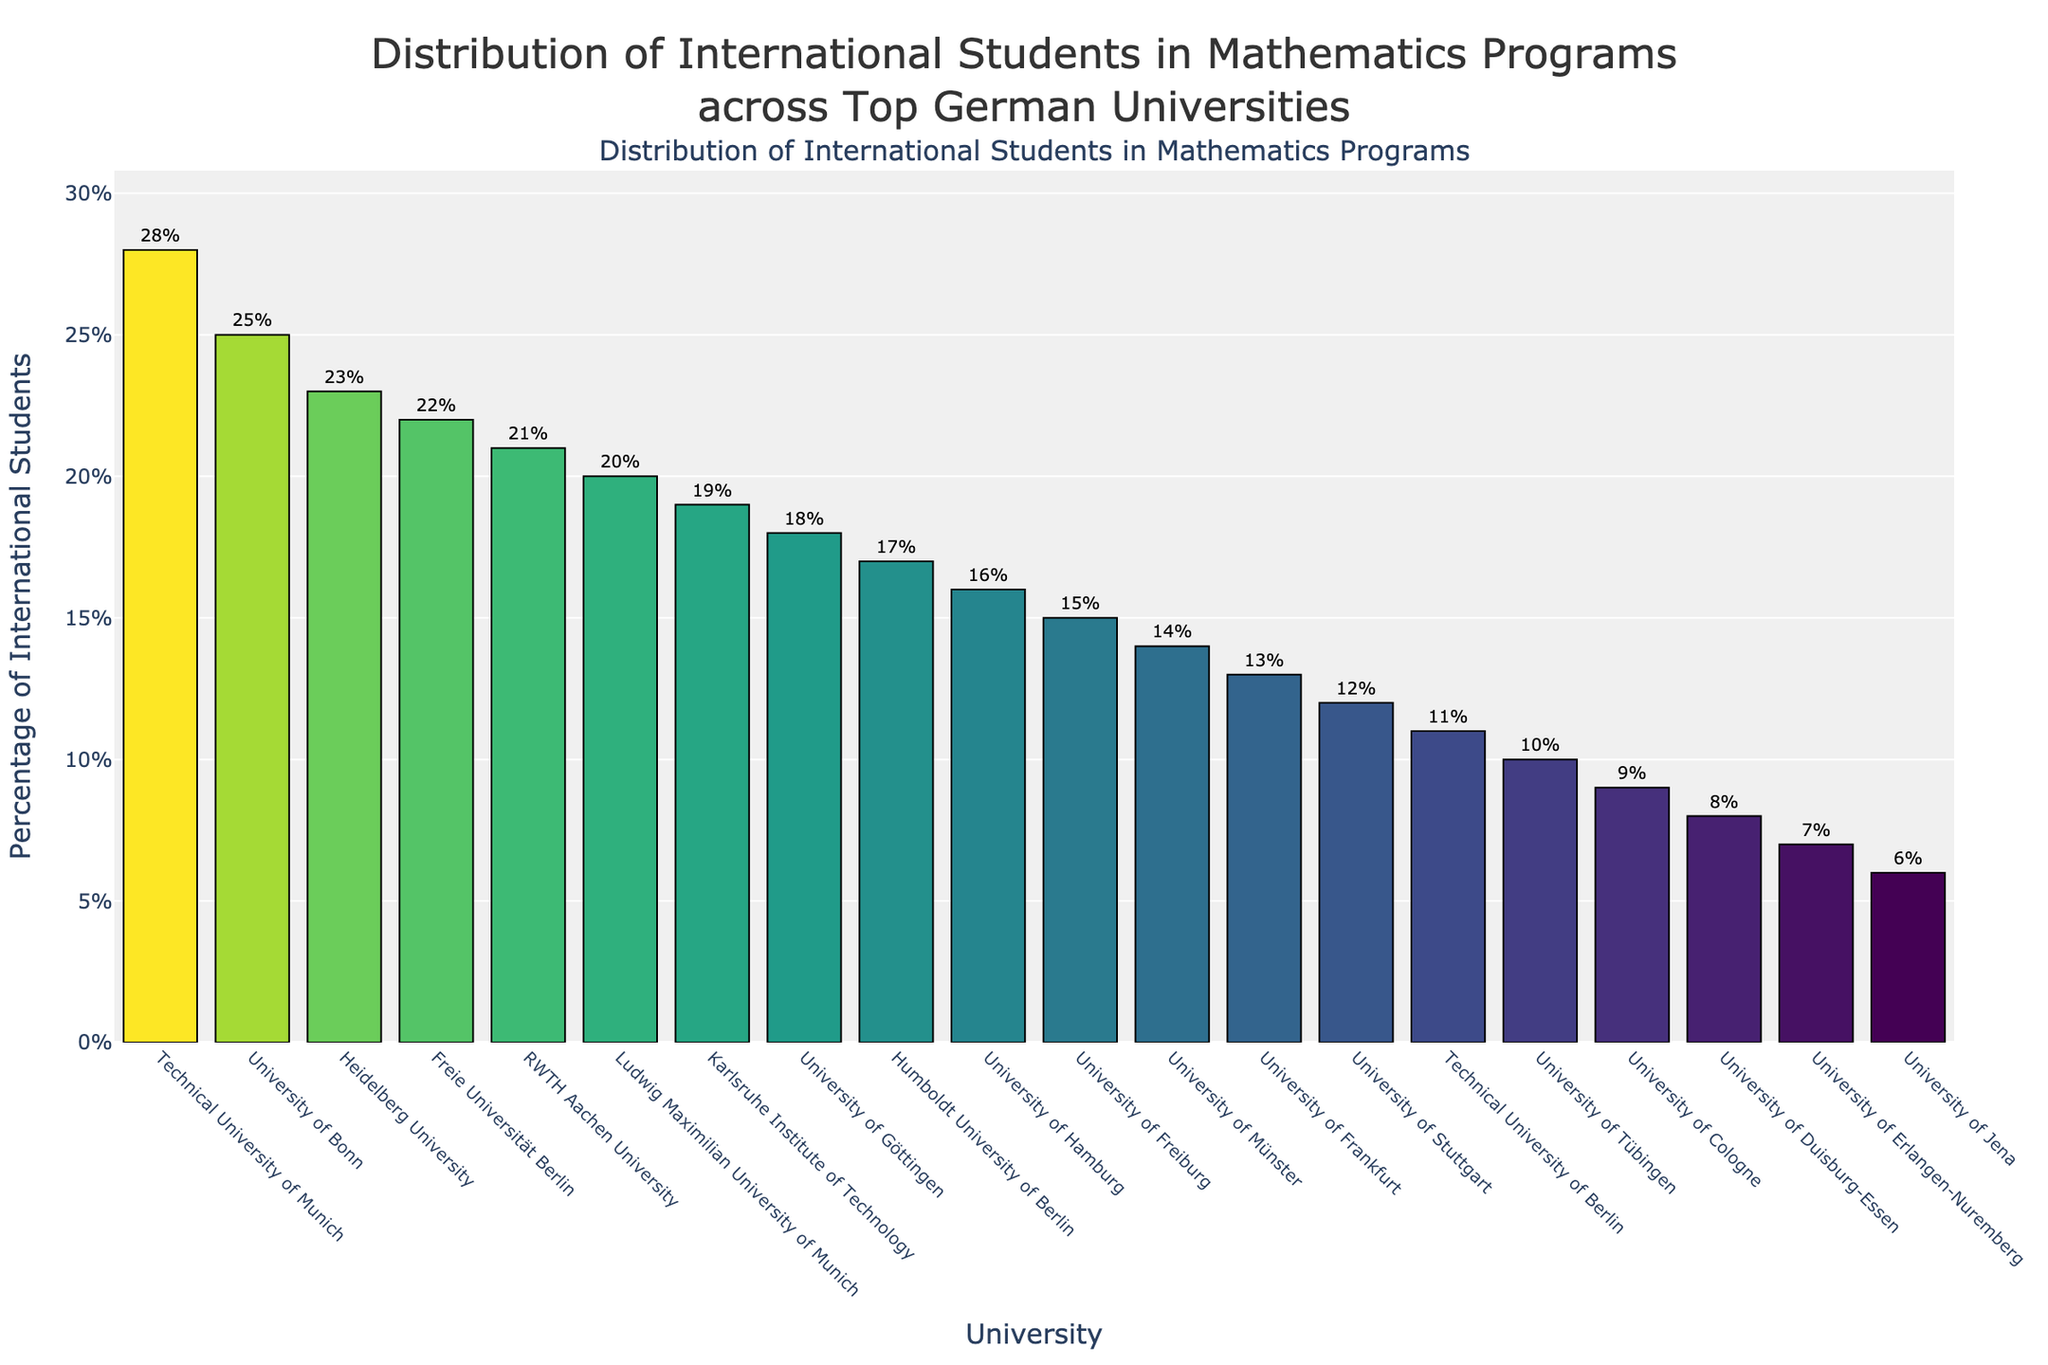Which university has the highest percentage of international students in its mathematics program? The university with the highest bar and the highest percentage label is the Technical University of Munich.
Answer: Technical University of Munich Which university has the lowest percentage of international students in its mathematics program? The university with the lowest bar and the lowest percentage label is the University of Jena.
Answer: University of Jena What is the percentage difference of international students between the University of Duisburg-Essen and the Technical University of Munich? The percentage for the Technical University of Munich is 28%, and for the University of Duisburg-Essen, it is 8%. The difference is 28% - 8% = 20%.
Answer: 20% What percentage of international students is at the University of Bonn, and how does it compare to the percentage at the University of Göttingen? The percentage at the University of Bonn is 25%, and at the University of Göttingen, it is 18%. The University of Bonn has 25% - 18% = 7% more international students than the University of Göttingen.
Answer: 7% Which universities have more than 20% international students in their mathematics programs? The universities with bars extending beyond the 20% line are Technical University of Munich, University of Bonn, Heidelberg University, and Freie Universität Berlin.
Answer: Technical University of Munich, University of Bonn, Heidelberg University, Freie Universität Berlin How many universities have a percentage of international students less than 15%? Counting the bars that do not reach the 15% mark, we have University of Münster, University of Frankfurt, University of Stuttgart, Technical University of Berlin, University of Tübingen, University of Cologne, University of Duisburg-Essen, University of Erlangen-Nuremberg, and University of Jena. That makes 9 universities.
Answer: 9 Compare the percentage of international students at the RWTH Aachen University and University of Cologne. Which one has more, and by how much? RWTH Aachen University has 21% and University of Cologne has 9%. The difference is 21% - 9% = 12%.
Answer: RWTH Aachen University by 12% What is the average percentage of international students across all the universities? Add up all the percentages and divide by the number of universities: (28 + 25 + 23 + 22 + 21 + 20 + 19 + 18 + 17 + 16 + 15 + 14 + 13 + 12 + 11 + 10 + 9 + 8 + 7 + 6) / 20 = 17%.
Answer: 17% What visual pattern can be observed in the distribution of international students among the universities? The bars tend to decrease in height from left to right, indicating a general decreasing trend in the percentage of international students as we move through the list of universities. This shows that only a few universities have a very high percentage, while most have moderate to low percentages.
Answer: Decreasing trend How does the percentage of international students at the Humboldt University of Berlin compare to the University of Freiburg? Humboldt University of Berlin has 17%, and University of Freiburg has 15%. Humboldt University of Berlin has 17% - 15% = 2% more.
Answer: 2% more 